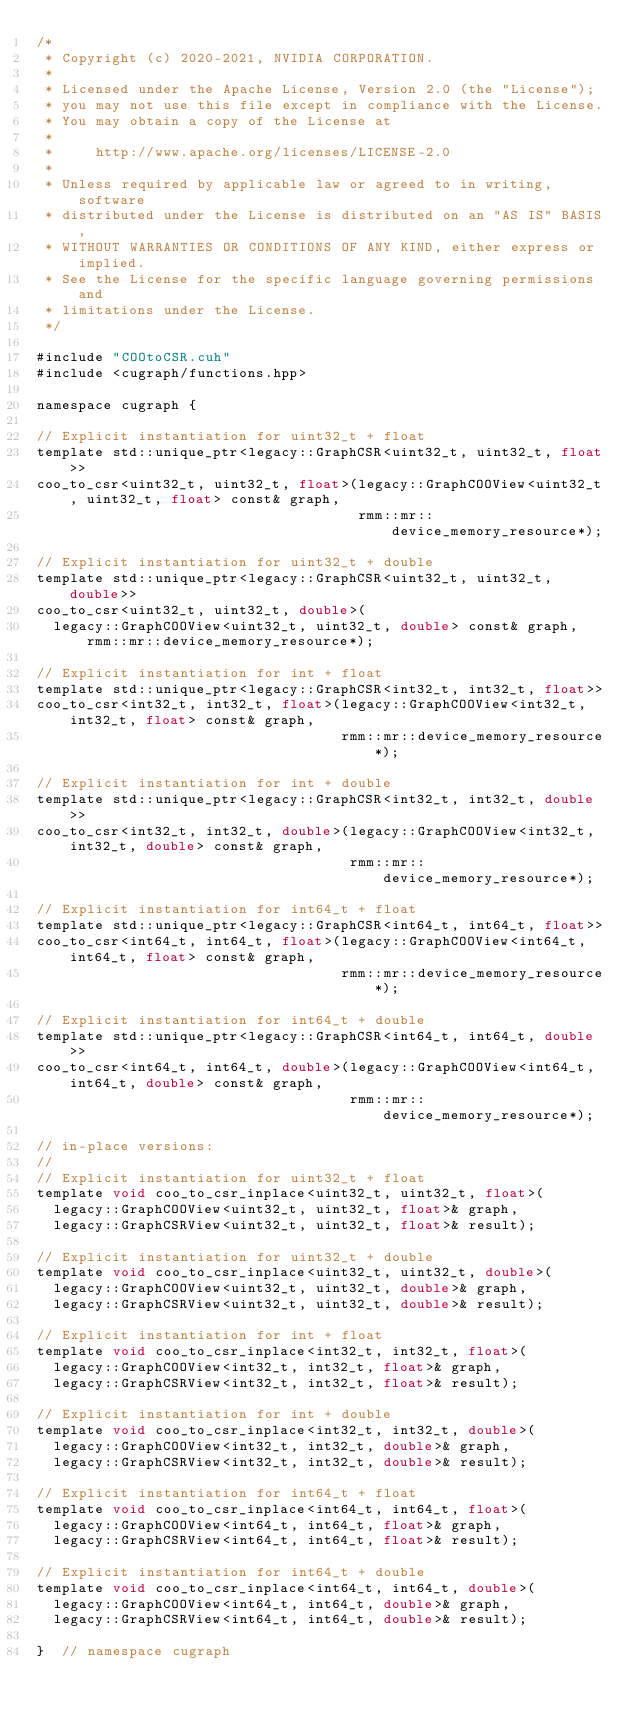Convert code to text. <code><loc_0><loc_0><loc_500><loc_500><_Cuda_>/*
 * Copyright (c) 2020-2021, NVIDIA CORPORATION.
 *
 * Licensed under the Apache License, Version 2.0 (the "License");
 * you may not use this file except in compliance with the License.
 * You may obtain a copy of the License at
 *
 *     http://www.apache.org/licenses/LICENSE-2.0
 *
 * Unless required by applicable law or agreed to in writing, software
 * distributed under the License is distributed on an "AS IS" BASIS,
 * WITHOUT WARRANTIES OR CONDITIONS OF ANY KIND, either express or implied.
 * See the License for the specific language governing permissions and
 * limitations under the License.
 */

#include "COOtoCSR.cuh"
#include <cugraph/functions.hpp>

namespace cugraph {

// Explicit instantiation for uint32_t + float
template std::unique_ptr<legacy::GraphCSR<uint32_t, uint32_t, float>>
coo_to_csr<uint32_t, uint32_t, float>(legacy::GraphCOOView<uint32_t, uint32_t, float> const& graph,
                                      rmm::mr::device_memory_resource*);

// Explicit instantiation for uint32_t + double
template std::unique_ptr<legacy::GraphCSR<uint32_t, uint32_t, double>>
coo_to_csr<uint32_t, uint32_t, double>(
  legacy::GraphCOOView<uint32_t, uint32_t, double> const& graph, rmm::mr::device_memory_resource*);

// Explicit instantiation for int + float
template std::unique_ptr<legacy::GraphCSR<int32_t, int32_t, float>>
coo_to_csr<int32_t, int32_t, float>(legacy::GraphCOOView<int32_t, int32_t, float> const& graph,
                                    rmm::mr::device_memory_resource*);

// Explicit instantiation for int + double
template std::unique_ptr<legacy::GraphCSR<int32_t, int32_t, double>>
coo_to_csr<int32_t, int32_t, double>(legacy::GraphCOOView<int32_t, int32_t, double> const& graph,
                                     rmm::mr::device_memory_resource*);

// Explicit instantiation for int64_t + float
template std::unique_ptr<legacy::GraphCSR<int64_t, int64_t, float>>
coo_to_csr<int64_t, int64_t, float>(legacy::GraphCOOView<int64_t, int64_t, float> const& graph,
                                    rmm::mr::device_memory_resource*);

// Explicit instantiation for int64_t + double
template std::unique_ptr<legacy::GraphCSR<int64_t, int64_t, double>>
coo_to_csr<int64_t, int64_t, double>(legacy::GraphCOOView<int64_t, int64_t, double> const& graph,
                                     rmm::mr::device_memory_resource*);

// in-place versions:
//
// Explicit instantiation for uint32_t + float
template void coo_to_csr_inplace<uint32_t, uint32_t, float>(
  legacy::GraphCOOView<uint32_t, uint32_t, float>& graph,
  legacy::GraphCSRView<uint32_t, uint32_t, float>& result);

// Explicit instantiation for uint32_t + double
template void coo_to_csr_inplace<uint32_t, uint32_t, double>(
  legacy::GraphCOOView<uint32_t, uint32_t, double>& graph,
  legacy::GraphCSRView<uint32_t, uint32_t, double>& result);

// Explicit instantiation for int + float
template void coo_to_csr_inplace<int32_t, int32_t, float>(
  legacy::GraphCOOView<int32_t, int32_t, float>& graph,
  legacy::GraphCSRView<int32_t, int32_t, float>& result);

// Explicit instantiation for int + double
template void coo_to_csr_inplace<int32_t, int32_t, double>(
  legacy::GraphCOOView<int32_t, int32_t, double>& graph,
  legacy::GraphCSRView<int32_t, int32_t, double>& result);

// Explicit instantiation for int64_t + float
template void coo_to_csr_inplace<int64_t, int64_t, float>(
  legacy::GraphCOOView<int64_t, int64_t, float>& graph,
  legacy::GraphCSRView<int64_t, int64_t, float>& result);

// Explicit instantiation for int64_t + double
template void coo_to_csr_inplace<int64_t, int64_t, double>(
  legacy::GraphCOOView<int64_t, int64_t, double>& graph,
  legacy::GraphCSRView<int64_t, int64_t, double>& result);

}  // namespace cugraph
</code> 